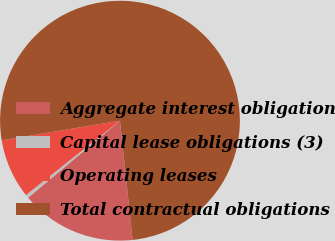Convert chart to OTSL. <chart><loc_0><loc_0><loc_500><loc_500><pie_chart><fcel>Aggregate interest obligation<fcel>Capital lease obligations (3)<fcel>Operating leases<fcel>Total contractual obligations<nl><fcel>15.57%<fcel>0.47%<fcel>8.02%<fcel>75.94%<nl></chart> 